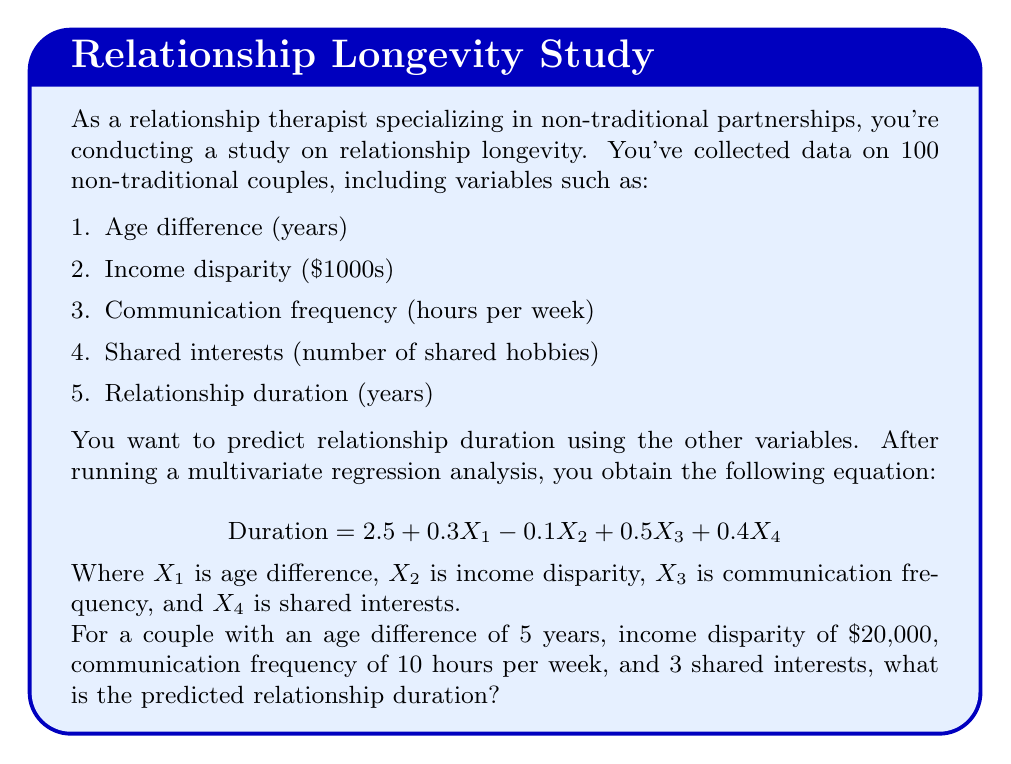Teach me how to tackle this problem. To solve this problem, we need to use the given multivariate regression equation and substitute the values for each variable:

$$ \text{Duration} = 2.5 + 0.3X_1 - 0.1X_2 + 0.5X_3 + 0.4X_4 $$

Given:
$X_1$ (age difference) = 5 years
$X_2$ (income disparity) = 20 ($20,000 ÷ $1000)
$X_3$ (communication frequency) = 10 hours per week
$X_4$ (shared interests) = 3

Let's substitute these values into the equation:

$$ \text{Duration} = 2.5 + 0.3(5) - 0.1(20) + 0.5(10) + 0.4(3) $$

Now, let's calculate each term:
1. Constant term: 2.5
2. Age difference term: $0.3 \times 5 = 1.5$
3. Income disparity term: $-0.1 \times 20 = -2$
4. Communication frequency term: $0.5 \times 10 = 5$
5. Shared interests term: $0.4 \times 3 = 1.2$

Adding all these terms:

$$ \text{Duration} = 2.5 + 1.5 - 2 + 5 + 1.2 = 8.2 $$

Therefore, the predicted relationship duration for this couple is 8.2 years.
Answer: 8.2 years 